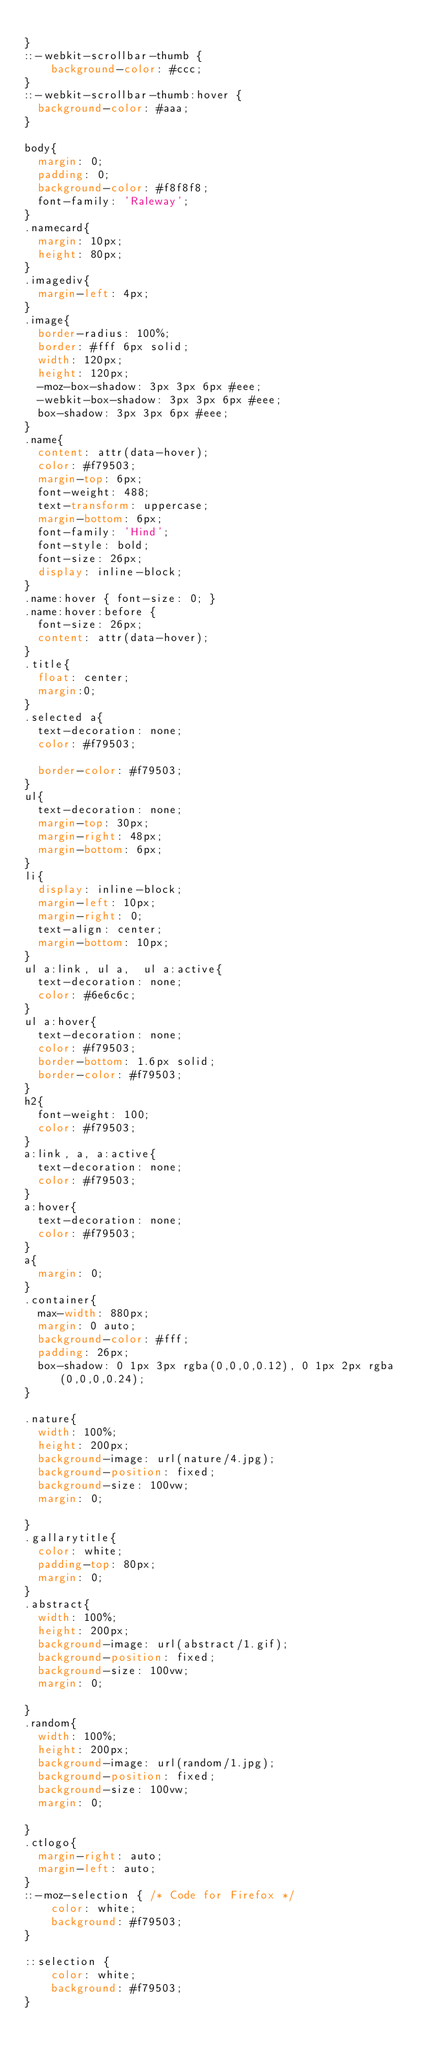<code> <loc_0><loc_0><loc_500><loc_500><_CSS_>
}
::-webkit-scrollbar-thumb {
    background-color: #ccc;
}
::-webkit-scrollbar-thumb:hover {
	background-color: #aaa;
}

body{
	margin: 0;
	padding: 0;
	background-color: #f8f8f8;
	font-family: 'Raleway';
}
.namecard{
	margin: 10px;
	height: 80px;
}
.imagediv{
	margin-left: 4px;
}
.image{
	border-radius: 100%;
	border: #fff 6px solid;
	width: 120px;
	height: 120px;
	-moz-box-shadow: 3px 3px 6px #eee;
	-webkit-box-shadow: 3px 3px 6px #eee;
	box-shadow: 3px 3px 6px #eee;
}
.name{
	content: attr(data-hover);
	color: #f79503;
	margin-top: 6px;
	font-weight: 488;
	text-transform: uppercase;
	margin-bottom: 6px;
	font-family: 'Hind';
	font-style: bold;
	font-size: 26px;
	display: inline-block;
}
.name:hover { font-size: 0; }
.name:hover:before {
	font-size: 26px;
	content: attr(data-hover);
}
.title{
	float: center;
	margin:0;
}
.selected a{
	text-decoration: none;
	color: #f79503;

	border-color: #f79503; 
}
ul{
	text-decoration: none;
	margin-top: 30px;
	margin-right: 48px;
	margin-bottom: 6px;
}
li{
	display: inline-block;
	margin-left: 10px;
	margin-right: 0;
	text-align: center;
	margin-bottom: 10px;
}
ul a:link, ul a,  ul a:active{
	text-decoration: none;
	color: #6e6c6c;
}
ul a:hover{
	text-decoration: none;
	color: #f79503;
	border-bottom: 1.6px solid;
	border-color: #f79503; 
}
h2{
	font-weight: 100;
	color: #f79503;
}
a:link, a, a:active{
	text-decoration: none;
	color: #f79503;
}
a:hover{
	text-decoration: none;
	color: #f79503;
}
a{
	margin: 0;
}
.container{
	max-width: 880px;
	margin: 0 auto;
	background-color: #fff;
	padding: 26px;
	box-shadow: 0 1px 3px rgba(0,0,0,0.12), 0 1px 2px rgba(0,0,0,0.24);
}

.nature{
	width: 100%;
	height: 200px;
	background-image: url(nature/4.jpg);
	background-position: fixed;
	background-size: 100vw;
	margin: 0;

}
.gallarytitle{
	color: white;
	padding-top: 80px;
	margin: 0;
}
.abstract{
	width: 100%;
	height: 200px;
	background-image: url(abstract/1.gif);
	background-position: fixed;
	background-size: 100vw;
	margin: 0;

}
.random{
	width: 100%;
	height: 200px;
	background-image: url(random/1.jpg);
	background-position: fixed;
	background-size: 100vw;
	margin: 0;

}
.ctlogo{
	margin-right: auto;
	margin-left: auto;
}
::-moz-selection { /* Code for Firefox */
    color: white;
    background: #f79503;
}

::selection {
    color: white; 
    background: #f79503;
}
</code> 